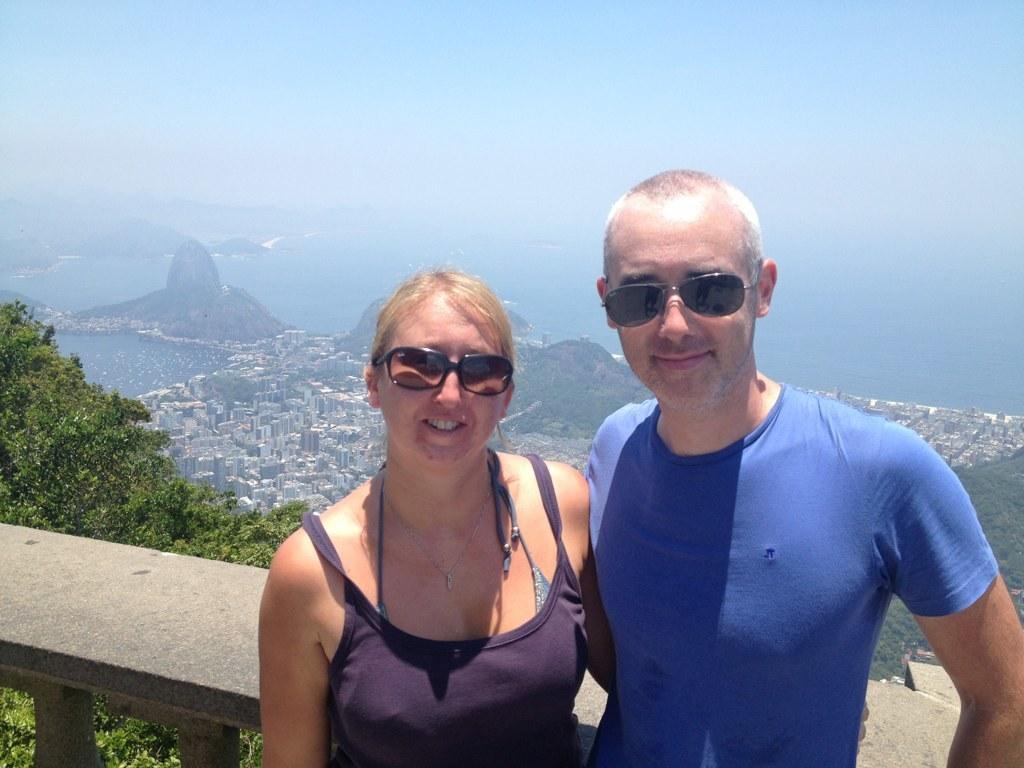Describe this image in one or two sentences. On the right side a man is standing, he wore blue color t-shirt, goggles. Beside him a beautiful woman is standing, she wore top, goggles. On the left side there are trees and water, at the top it is the sky. 